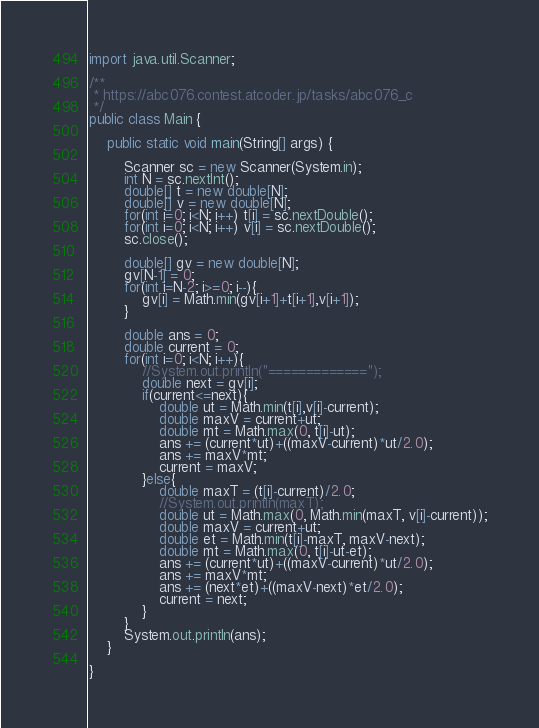<code> <loc_0><loc_0><loc_500><loc_500><_Java_>import java.util.Scanner;

/**
 * https://abc076.contest.atcoder.jp/tasks/abc076_c
 */
public class Main {

	public static void main(String[] args) {
		
		Scanner sc = new Scanner(System.in);
		int N = sc.nextInt();
		double[] t = new double[N];
		double[] v = new double[N];
		for(int i=0; i<N; i++) t[i] = sc.nextDouble();
		for(int i=0; i<N; i++) v[i] = sc.nextDouble();
		sc.close();
		
		double[] gv = new double[N];
		gv[N-1] = 0;
		for(int i=N-2; i>=0; i--){
			gv[i] = Math.min(gv[i+1]+t[i+1],v[i+1]);
		}
		
		double ans = 0;
		double current = 0;
		for(int i=0; i<N; i++){
			//System.out.println("=============");
			double next = gv[i];
			if(current<=next){
				double ut = Math.min(t[i],v[i]-current);
				double maxV = current+ut;
				double mt = Math.max(0, t[i]-ut);
				ans += (current*ut)+((maxV-current)*ut/2.0);
				ans += maxV*mt;
				current = maxV;
			}else{
				double maxT = (t[i]-current)/2.0;
				//System.out.println(maxT);
				double ut = Math.max(0, Math.min(maxT, v[i]-current));
				double maxV = current+ut;
				double et = Math.min(t[i]-maxT, maxV-next);
				double mt = Math.max(0, t[i]-ut-et);
				ans += (current*ut)+((maxV-current)*ut/2.0);
				ans += maxV*mt;
				ans += (next*et)+((maxV-next)*et/2.0);
				current = next;
			}
		}
		System.out.println(ans);
	}

}
</code> 